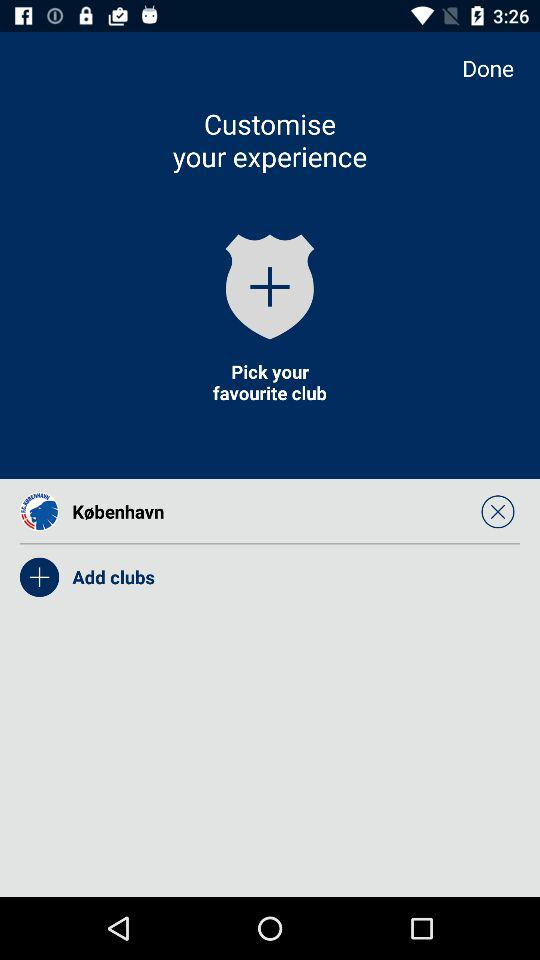Which club is selected? The selected club is "F.C. Copenhagen". 